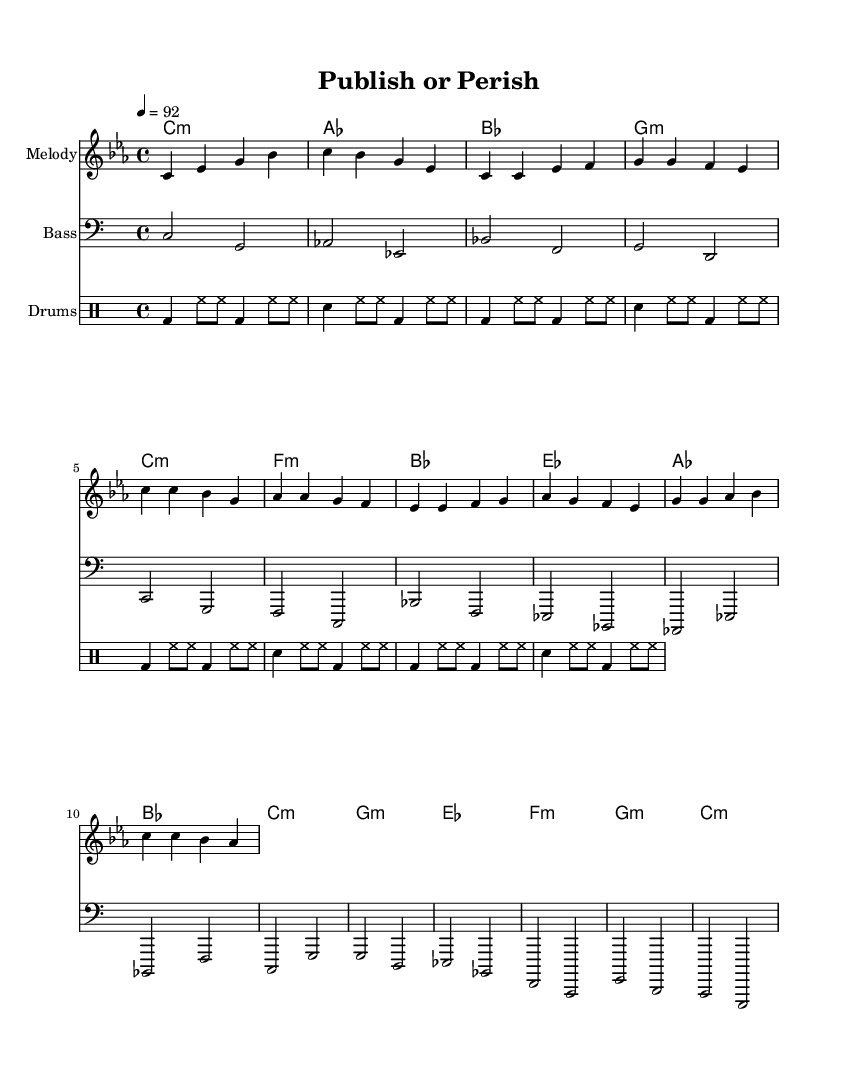What is the key signature of this music? The key signature is C minor, which has three flats (B flat, E flat, and A flat). It can be identified by looking at the beginning of the staff where the flats are placed.
Answer: C minor What is the time signature of this piece? The time signature is 4/4, which means there are 4 beats in each measure and the quarter note receives one beat. This can be found near the beginning of the sheet music.
Answer: 4/4 What is the tempo marking given in this piece? The tempo marking indicates the speed of the music, and it is set to 92 beats per minute. This can be found near the start of the music, specifically indicated in the tempo directive.
Answer: 92 How many measures are in the Chorus section? The Chorus section comprises two measures as indicated by the repeated musical phrases that fill the stave within that section.
Answer: 2 What is the main theme of the lyrics suggested in this rap? The main theme appears to critique the pressure to publish in academia, as implied by the title "Publish or Perish." This theme resonates through the rhythmic and lyrical structure unique to rap.
Answer: Critique of academic pressure What type of rhythm pattern does the drum part follow? The drum part follows a standard hip-hop pattern characterized by a kick-snare configuration interspersed with hi-hats, which is typical in rap music. This can be discerned by observing the arrangement of note values in the drum staff.
Answer: Hip-hop pattern What is the tonic chord in this piece? The tonic chord is the root chord of the key signature. For C minor, the tonic chord is C minor itself, indicated in the harmonies section.
Answer: C minor 